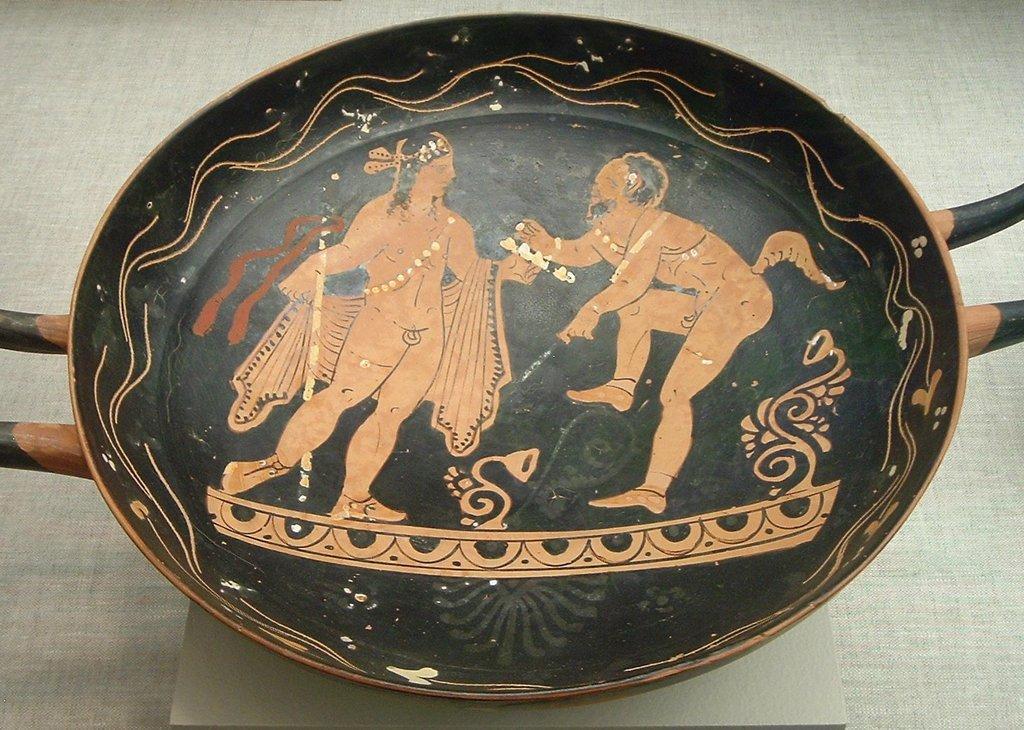Please provide a concise description of this image. In this image, we can see a man. On that man, we can see a pan, on that pan, we can see two men. In the background, we can also see gray color. 